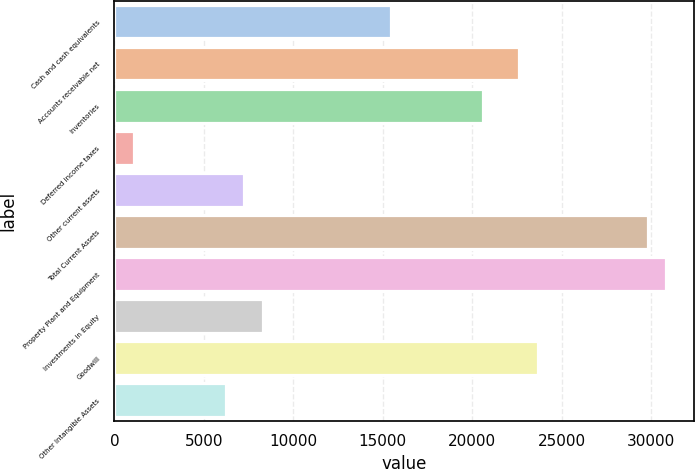<chart> <loc_0><loc_0><loc_500><loc_500><bar_chart><fcel>Cash and cash equivalents<fcel>Accounts receivable net<fcel>Inventories<fcel>Deferred income taxes<fcel>Other current assets<fcel>Total Current Assets<fcel>Property Plant and Equipment<fcel>Investments in Equity<fcel>Goodwill<fcel>Other Intangible Assets<nl><fcel>15454<fcel>22629<fcel>20579<fcel>1104<fcel>7254<fcel>29804<fcel>30829<fcel>8279<fcel>23654<fcel>6229<nl></chart> 